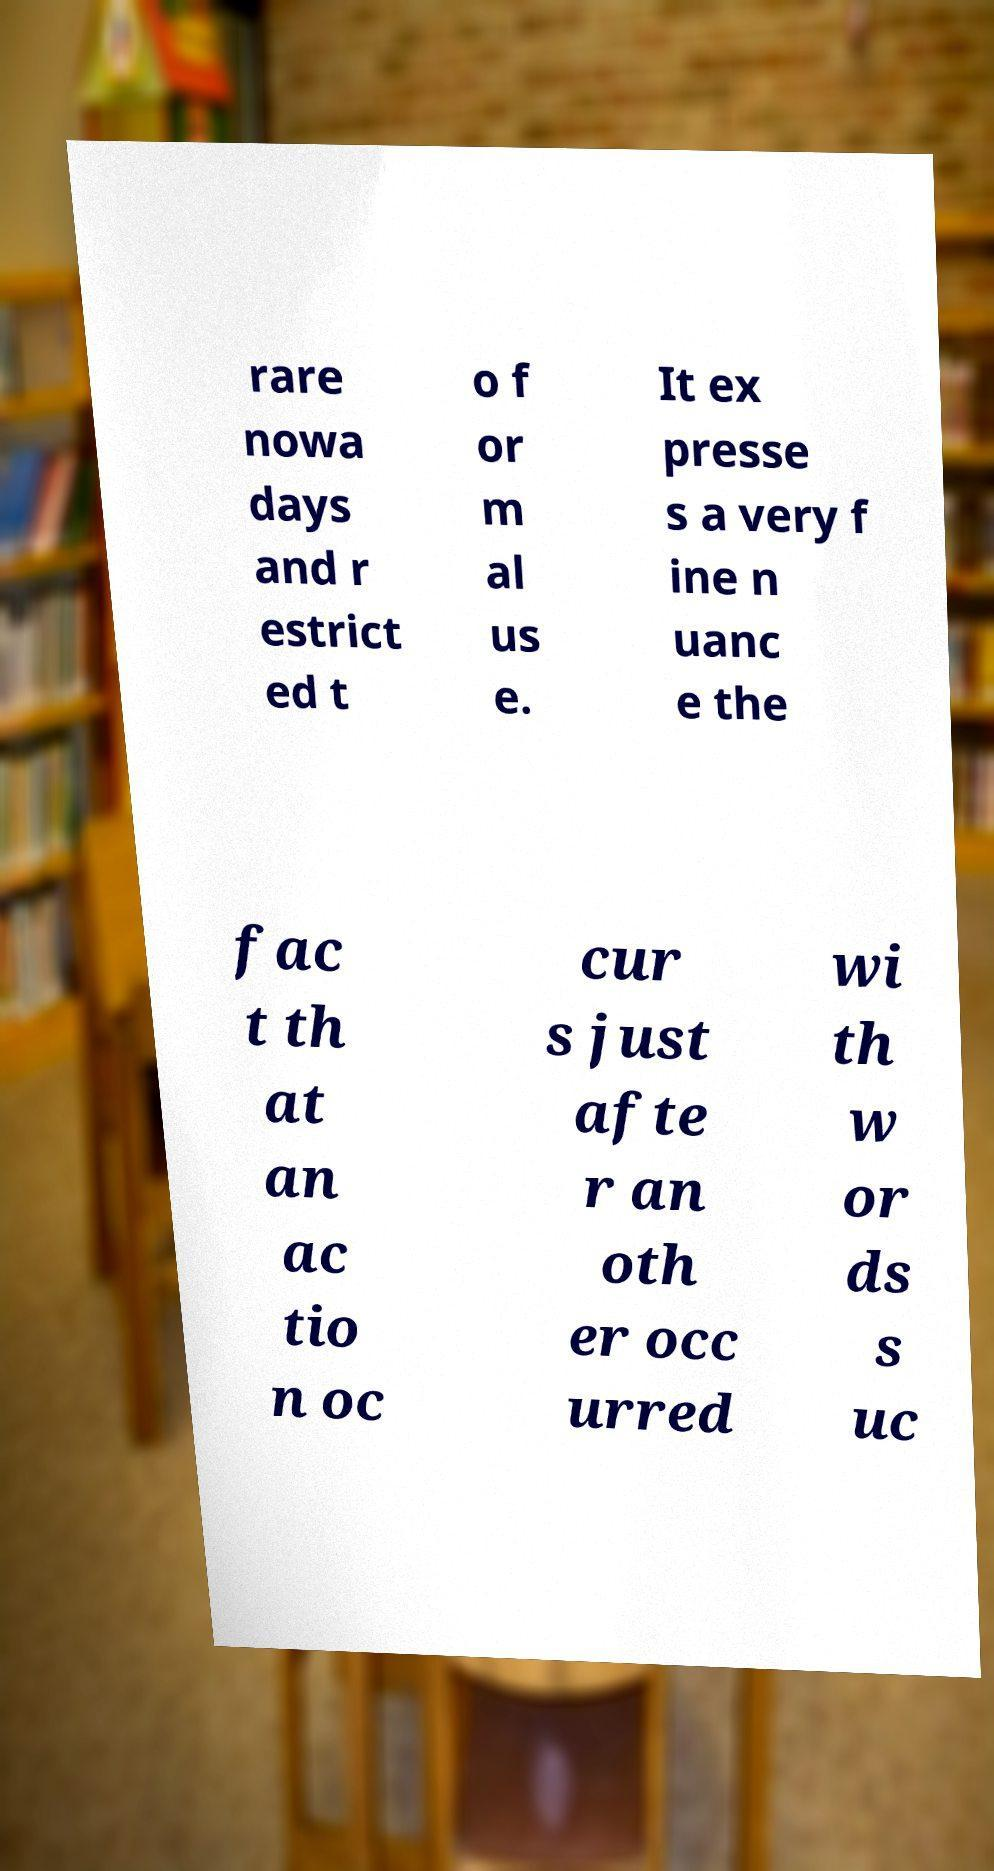Can you read and provide the text displayed in the image?This photo seems to have some interesting text. Can you extract and type it out for me? rare nowa days and r estrict ed t o f or m al us e. It ex presse s a very f ine n uanc e the fac t th at an ac tio n oc cur s just afte r an oth er occ urred wi th w or ds s uc 